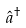Convert formula to latex. <formula><loc_0><loc_0><loc_500><loc_500>\hat { a } ^ { \dagger }</formula> 